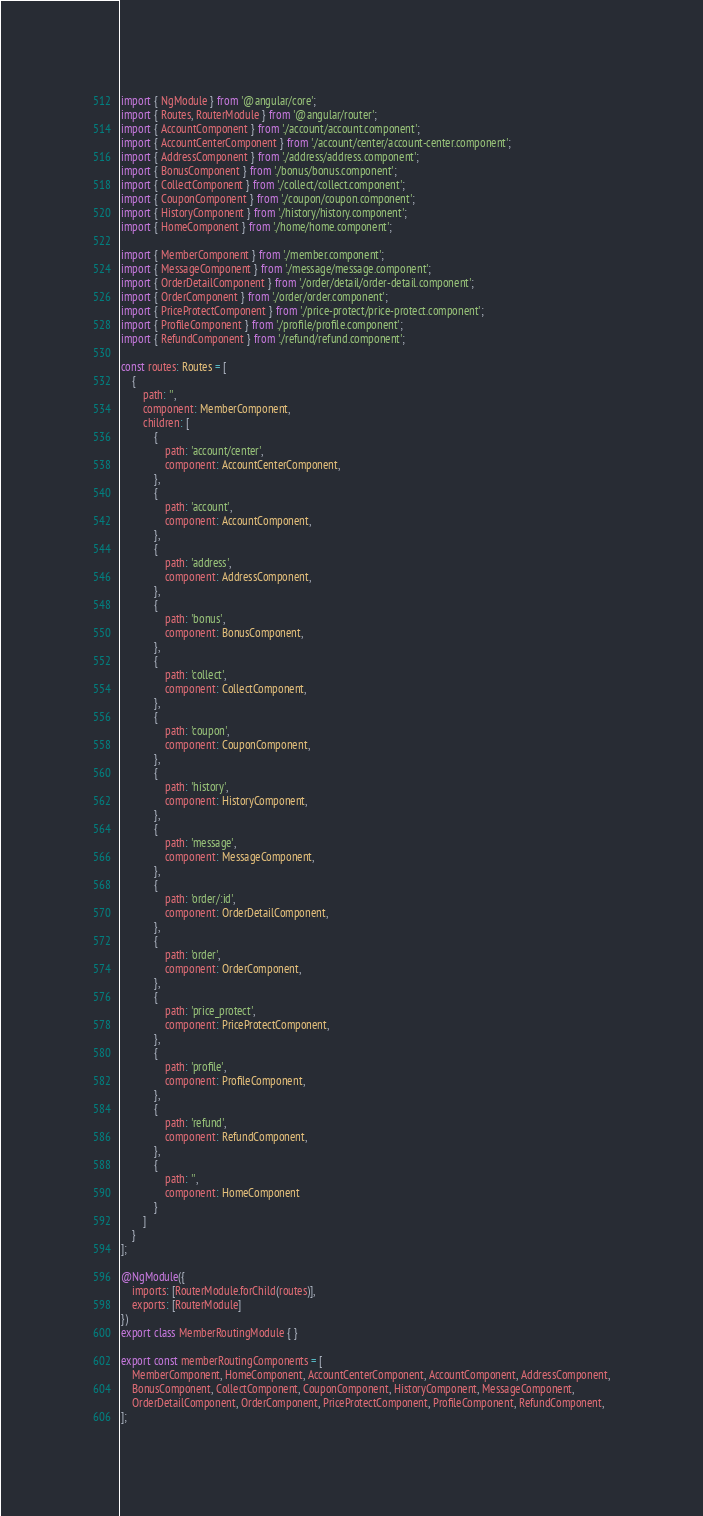Convert code to text. <code><loc_0><loc_0><loc_500><loc_500><_TypeScript_>import { NgModule } from '@angular/core';
import { Routes, RouterModule } from '@angular/router';
import { AccountComponent } from './account/account.component';
import { AccountCenterComponent } from './account/center/account-center.component';
import { AddressComponent } from './address/address.component';
import { BonusComponent } from './bonus/bonus.component';
import { CollectComponent } from './collect/collect.component';
import { CouponComponent } from './coupon/coupon.component';
import { HistoryComponent } from './history/history.component';
import { HomeComponent } from './home/home.component';

import { MemberComponent } from './member.component';
import { MessageComponent } from './message/message.component';
import { OrderDetailComponent } from './order/detail/order-detail.component';
import { OrderComponent } from './order/order.component';
import { PriceProtectComponent } from './price-protect/price-protect.component';
import { ProfileComponent } from './profile/profile.component';
import { RefundComponent } from './refund/refund.component';

const routes: Routes = [
    {
        path: '',
        component: MemberComponent,
        children: [
            {
                path: 'account/center',
                component: AccountCenterComponent,
            },
            {
                path: 'account',
                component: AccountComponent,
            },
            {
                path: 'address',
                component: AddressComponent,
            },
            {
                path: 'bonus',
                component: BonusComponent,
            },
            {
                path: 'collect',
                component: CollectComponent,
            },
            {
                path: 'coupon',
                component: CouponComponent,
            },
            {
                path: 'history',
                component: HistoryComponent,
            },
            {
                path: 'message',
                component: MessageComponent,
            },
            {
                path: 'order/:id',
                component: OrderDetailComponent,
            },
            {
                path: 'order',
                component: OrderComponent,
            },
            {
                path: 'price_protect',
                component: PriceProtectComponent,
            },
            {
                path: 'profile',
                component: ProfileComponent,
            },
            {
                path: 'refund',
                component: RefundComponent,
            },
            {
                path: '',
                component: HomeComponent
            }
        ]
    }
];

@NgModule({
    imports: [RouterModule.forChild(routes)],
    exports: [RouterModule]
})
export class MemberRoutingModule { }

export const memberRoutingComponents = [
    MemberComponent, HomeComponent, AccountCenterComponent, AccountComponent, AddressComponent,
    BonusComponent, CollectComponent, CouponComponent, HistoryComponent, MessageComponent,
    OrderDetailComponent, OrderComponent, PriceProtectComponent, ProfileComponent, RefundComponent,
];
</code> 